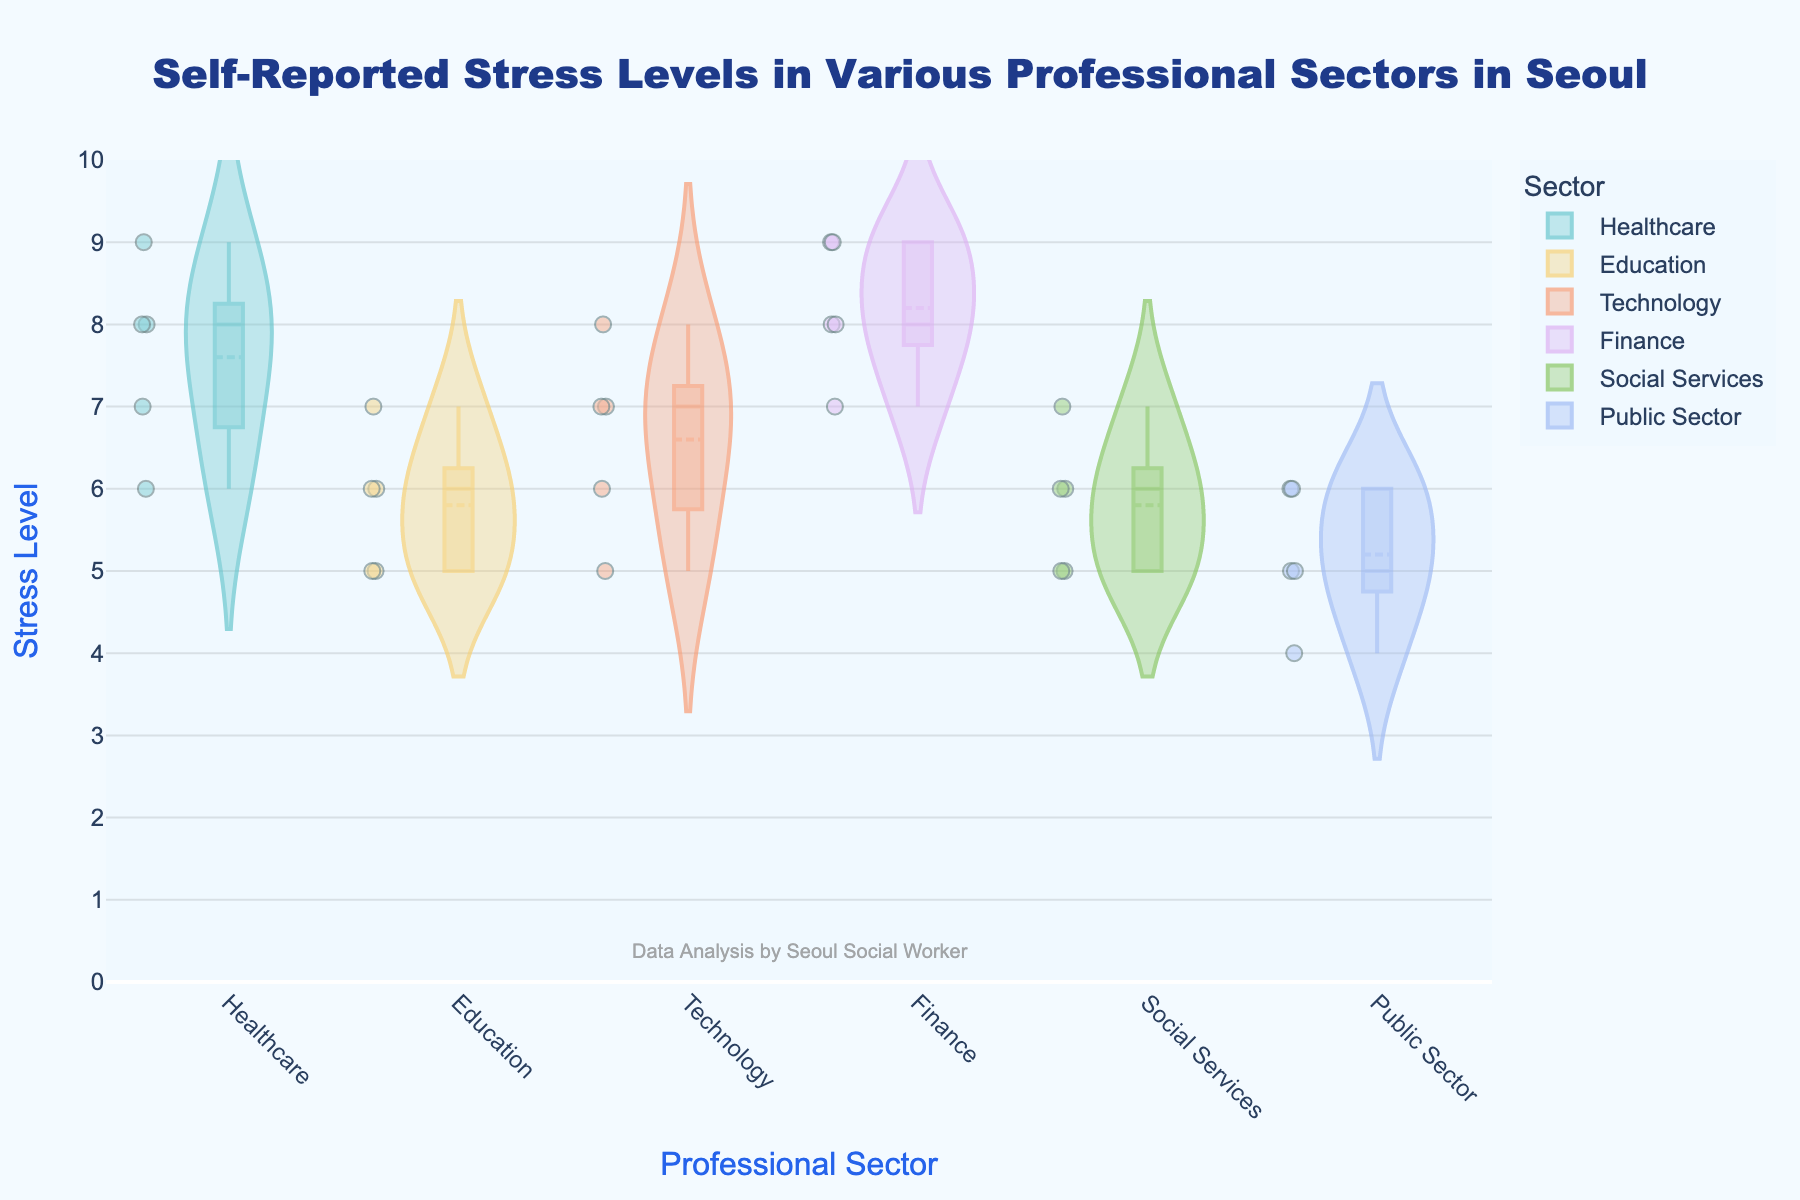what is the title of the chart? The title is prominently displayed at the top center of the chart in a larger font size and bold style.
Answer: Self-Reported Stress Levels in Various Professional Sectors in Seoul Which sector shows the widest distribution of stress levels? By examining the width and spread of each violin plot, the Finance sector has the widest distribution, indicating the greatest variability in stress levels.
Answer: Finance What is the median stress level in the Healthcare sector? The box within the violin plot of the Healthcare sector indicates the median level, which is clearly visible at a specific value.
Answer: 8 Which sector has the highest median stress level? By comparing the medians of all the sectors, indicated by the middle line in each box plot, the Finance sector shows the highest median stress level.
Answer: Finance Which sector has the lowest spread in stress levels? By observing the range and spread of data points within the violin plots, the Education sector has the narrowest spread, indicating less variability.
Answer: Education Are there any sectors with overlapping stress levels? By analyzing the overlapping areas of the violin plots, we can see that there is overlap in stress levels between multiple sectors, such as Social Services and Education.
Answer: Yes What is the upper quartile stress level for the Technology sector? The upper quartile, indicated by the top of the box in the violin plot for the Technology sector, represents the 75th percentile.
Answer: 7 How does the median stress level in Healthcare compare to that in Education? By comparing the median lines in the boxes of both Healthcare and Education sectors, Healthcare has a higher median stress level than Education.
Answer: Higher Which sector shows the least number of outliers? By looking at the individual scattered points outside the main distribution in each sector, Healthcare has the least number of outliers.
Answer: Healthcare Based on the data, which sector seems to have stress levels most concentrated around their median? By examining the density and concentration of the jittered points in each violin plot, the Technology sector has stress levels most concentrated around its median.
Answer: Technology 